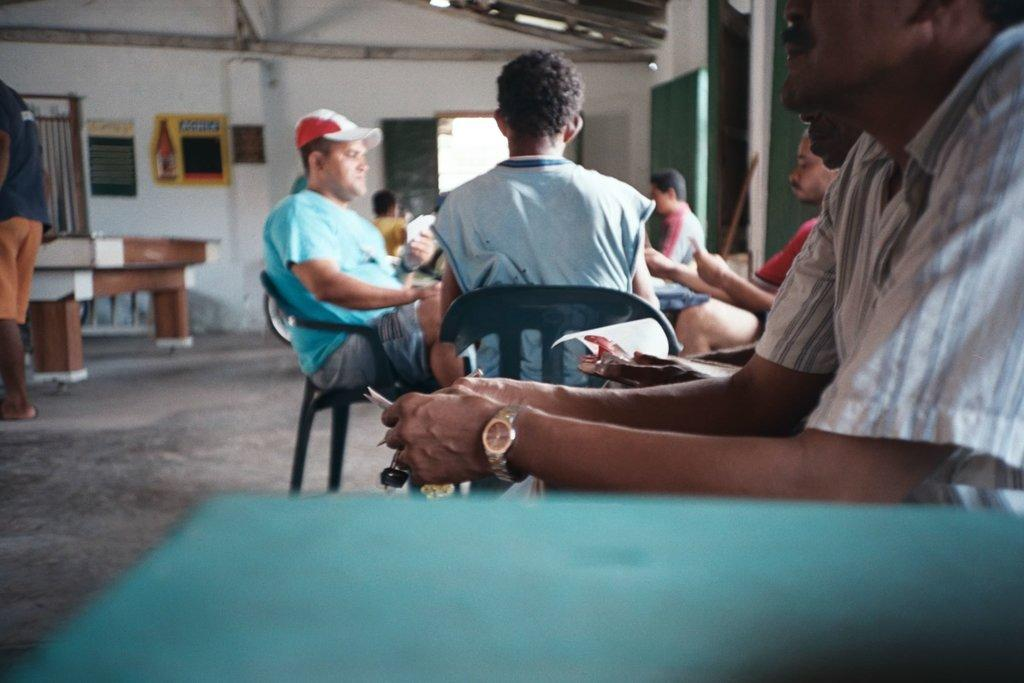What are the people in the image doing? The group of people is sitting in chairs near a table. What can be seen on the wall in the background? There is a frame attached to a wall in the background. What is the position of the other person in the image? There is another person standing in the image. What is the main piece of furniture in the image? There is a table in the image. What architectural features are present in the image? There is a window and a door in the image. What type of berry is being used as a decoration on the table in the image? There is no berry present on the table in the image. What kind of lumber is visible in the image? There is no lumber visible in the image. 